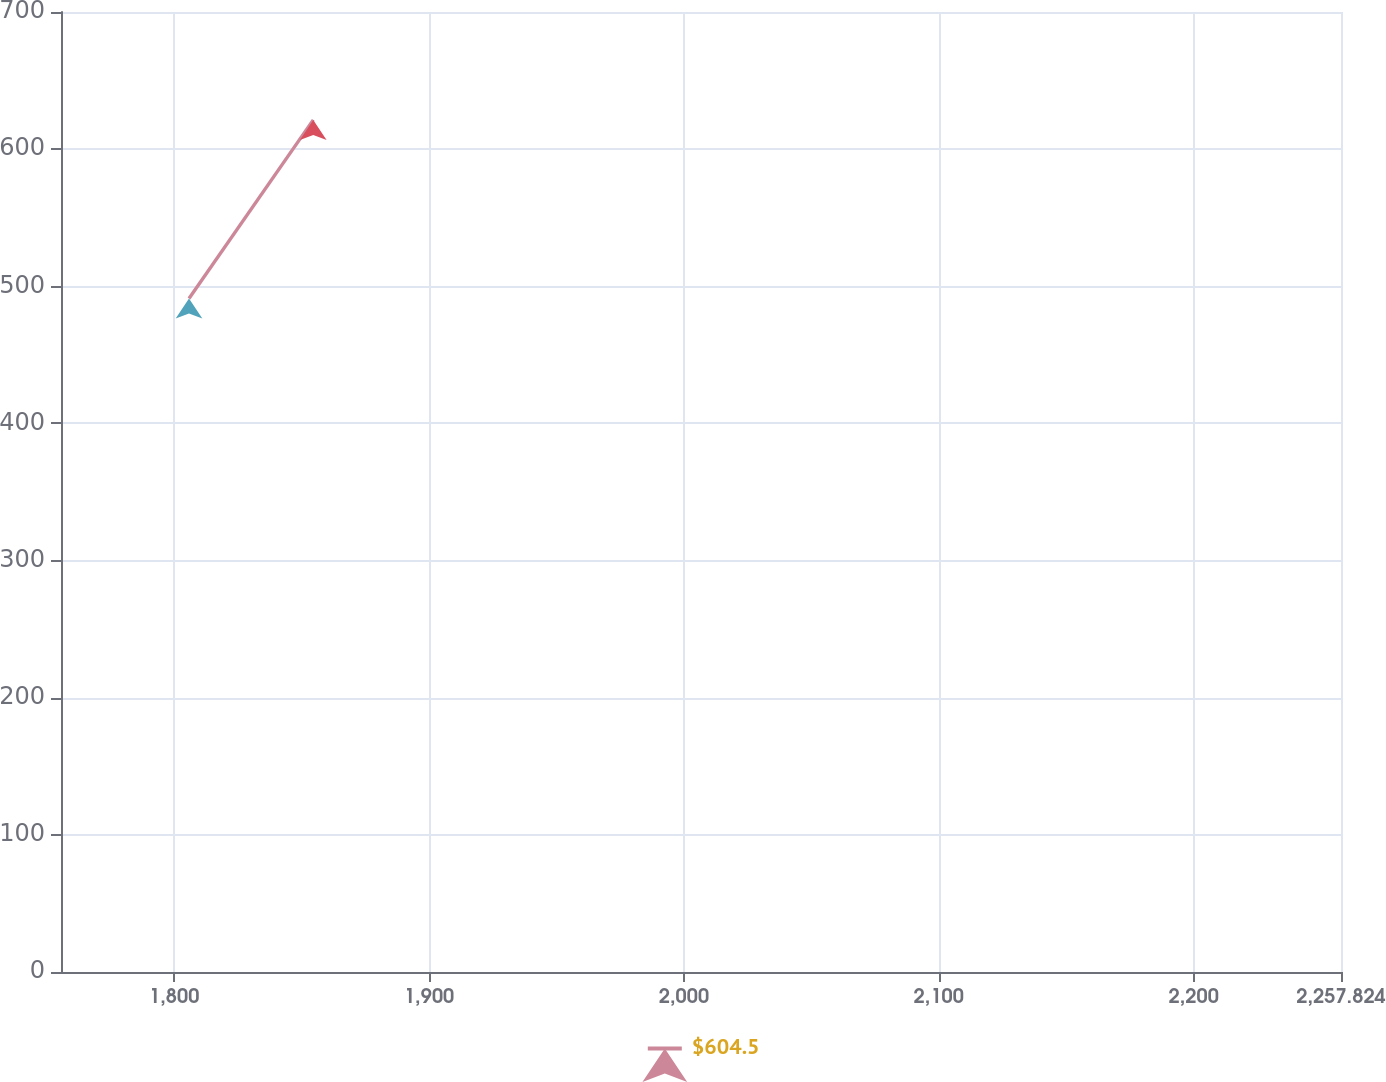<chart> <loc_0><loc_0><loc_500><loc_500><line_chart><ecel><fcel>$604.5<nl><fcel>1805.79<fcel>491.12<nl><fcel>1854.55<fcel>621.34<nl><fcel>2259.29<fcel>600.01<nl><fcel>2308.05<fcel>550.73<nl></chart> 